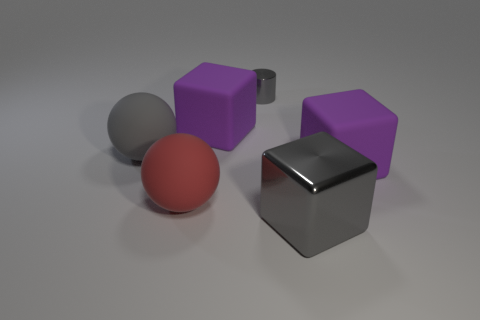Add 1 red shiny things. How many objects exist? 7 Subtract all cylinders. How many objects are left? 5 Add 6 purple rubber cubes. How many purple rubber cubes are left? 8 Add 3 rubber objects. How many rubber objects exist? 7 Subtract 0 cyan cylinders. How many objects are left? 6 Subtract all large red matte spheres. Subtract all purple rubber blocks. How many objects are left? 3 